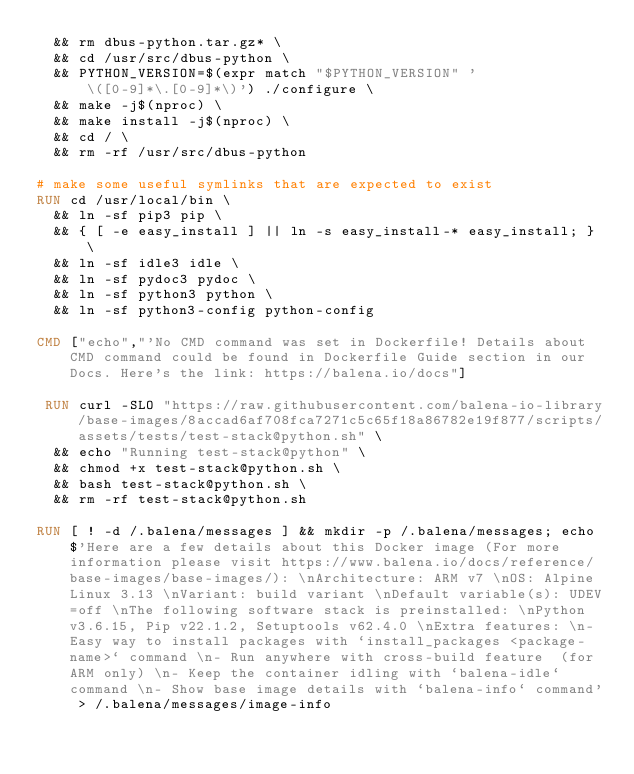Convert code to text. <code><loc_0><loc_0><loc_500><loc_500><_Dockerfile_>	&& rm dbus-python.tar.gz* \
	&& cd /usr/src/dbus-python \
	&& PYTHON_VERSION=$(expr match "$PYTHON_VERSION" '\([0-9]*\.[0-9]*\)') ./configure \
	&& make -j$(nproc) \
	&& make install -j$(nproc) \
	&& cd / \
	&& rm -rf /usr/src/dbus-python

# make some useful symlinks that are expected to exist
RUN cd /usr/local/bin \
	&& ln -sf pip3 pip \
	&& { [ -e easy_install ] || ln -s easy_install-* easy_install; } \
	&& ln -sf idle3 idle \
	&& ln -sf pydoc3 pydoc \
	&& ln -sf python3 python \
	&& ln -sf python3-config python-config

CMD ["echo","'No CMD command was set in Dockerfile! Details about CMD command could be found in Dockerfile Guide section in our Docs. Here's the link: https://balena.io/docs"]

 RUN curl -SLO "https://raw.githubusercontent.com/balena-io-library/base-images/8accad6af708fca7271c5c65f18a86782e19f877/scripts/assets/tests/test-stack@python.sh" \
  && echo "Running test-stack@python" \
  && chmod +x test-stack@python.sh \
  && bash test-stack@python.sh \
  && rm -rf test-stack@python.sh 

RUN [ ! -d /.balena/messages ] && mkdir -p /.balena/messages; echo $'Here are a few details about this Docker image (For more information please visit https://www.balena.io/docs/reference/base-images/base-images/): \nArchitecture: ARM v7 \nOS: Alpine Linux 3.13 \nVariant: build variant \nDefault variable(s): UDEV=off \nThe following software stack is preinstalled: \nPython v3.6.15, Pip v22.1.2, Setuptools v62.4.0 \nExtra features: \n- Easy way to install packages with `install_packages <package-name>` command \n- Run anywhere with cross-build feature  (for ARM only) \n- Keep the container idling with `balena-idle` command \n- Show base image details with `balena-info` command' > /.balena/messages/image-info</code> 